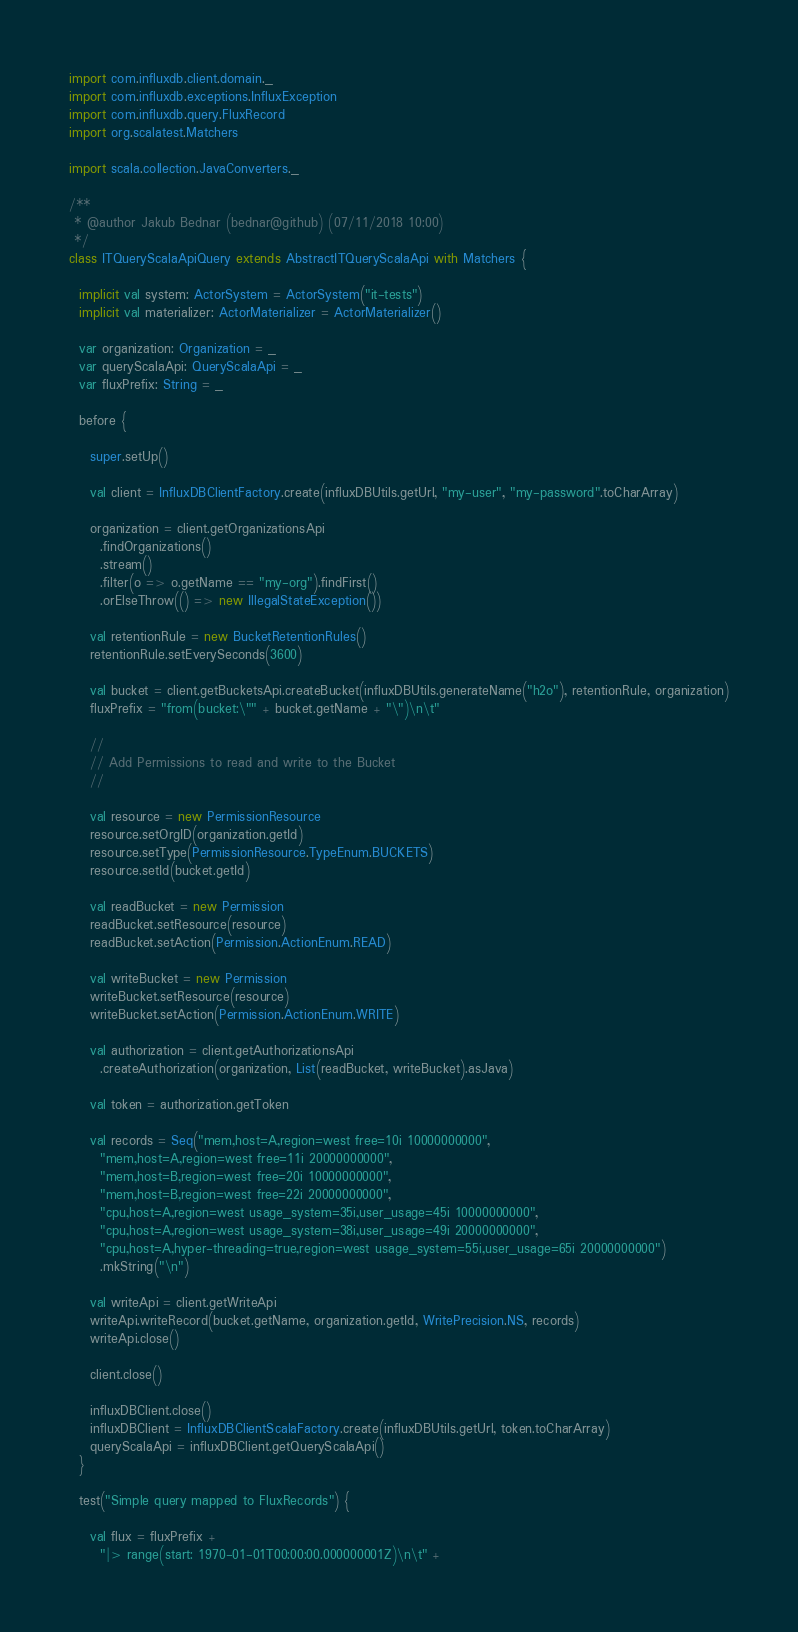<code> <loc_0><loc_0><loc_500><loc_500><_Scala_>import com.influxdb.client.domain._
import com.influxdb.exceptions.InfluxException
import com.influxdb.query.FluxRecord
import org.scalatest.Matchers

import scala.collection.JavaConverters._

/**
 * @author Jakub Bednar (bednar@github) (07/11/2018 10:00)
 */
class ITQueryScalaApiQuery extends AbstractITQueryScalaApi with Matchers {

  implicit val system: ActorSystem = ActorSystem("it-tests")
  implicit val materializer: ActorMaterializer = ActorMaterializer()

  var organization: Organization = _
  var queryScalaApi: QueryScalaApi = _
  var fluxPrefix: String = _

  before {

    super.setUp()

    val client = InfluxDBClientFactory.create(influxDBUtils.getUrl, "my-user", "my-password".toCharArray)

    organization = client.getOrganizationsApi
      .findOrganizations()
      .stream()
      .filter(o => o.getName == "my-org").findFirst()
      .orElseThrow(() => new IllegalStateException())

    val retentionRule = new BucketRetentionRules()
    retentionRule.setEverySeconds(3600)

    val bucket = client.getBucketsApi.createBucket(influxDBUtils.generateName("h2o"), retentionRule, organization)
    fluxPrefix = "from(bucket:\"" + bucket.getName + "\")\n\t"

    //
    // Add Permissions to read and write to the Bucket
    //

    val resource = new PermissionResource
    resource.setOrgID(organization.getId)
    resource.setType(PermissionResource.TypeEnum.BUCKETS)
    resource.setId(bucket.getId)

    val readBucket = new Permission
    readBucket.setResource(resource)
    readBucket.setAction(Permission.ActionEnum.READ)

    val writeBucket = new Permission
    writeBucket.setResource(resource)
    writeBucket.setAction(Permission.ActionEnum.WRITE)

    val authorization = client.getAuthorizationsApi
      .createAuthorization(organization, List(readBucket, writeBucket).asJava)

    val token = authorization.getToken

    val records = Seq("mem,host=A,region=west free=10i 10000000000",
      "mem,host=A,region=west free=11i 20000000000",
      "mem,host=B,region=west free=20i 10000000000",
      "mem,host=B,region=west free=22i 20000000000",
      "cpu,host=A,region=west usage_system=35i,user_usage=45i 10000000000",
      "cpu,host=A,region=west usage_system=38i,user_usage=49i 20000000000",
      "cpu,host=A,hyper-threading=true,region=west usage_system=55i,user_usage=65i 20000000000")
      .mkString("\n")

    val writeApi = client.getWriteApi
    writeApi.writeRecord(bucket.getName, organization.getId, WritePrecision.NS, records)
    writeApi.close()

    client.close()

    influxDBClient.close()
    influxDBClient = InfluxDBClientScalaFactory.create(influxDBUtils.getUrl, token.toCharArray)
    queryScalaApi = influxDBClient.getQueryScalaApi()
  }

  test("Simple query mapped to FluxRecords") {

    val flux = fluxPrefix +
      "|> range(start: 1970-01-01T00:00:00.000000001Z)\n\t" +</code> 